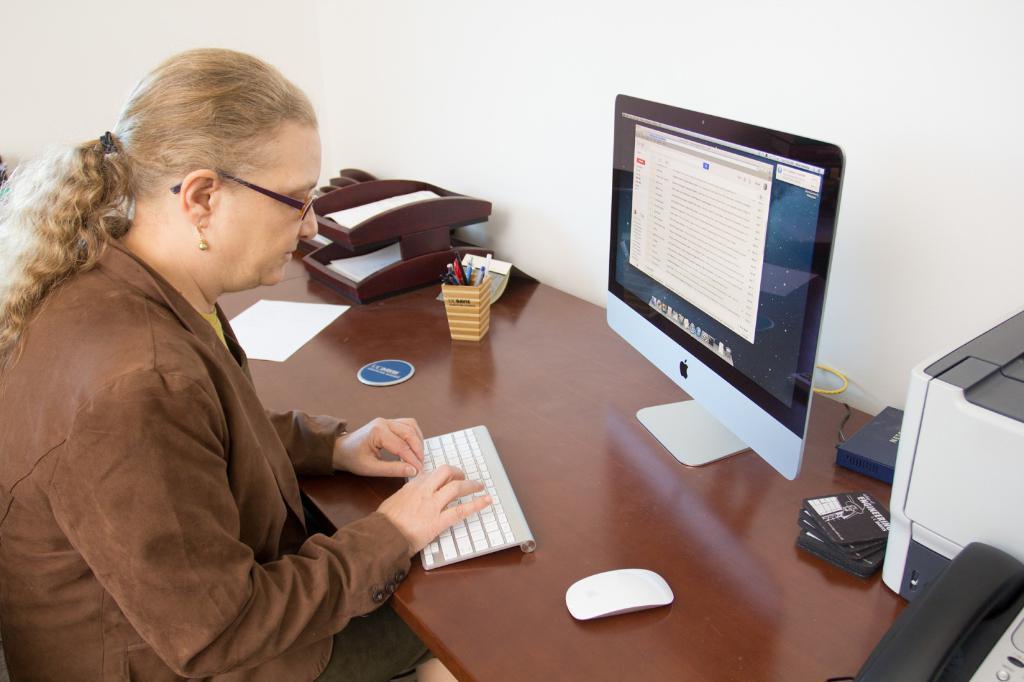Could you give a brief overview of what you see in this image? A woman who wore a brown jacket with grey hair have spectacles with the system which is on the table. And the table has some things like pen stand, paper, paper stand and also has a mouse and a telephone and printer machine on the table. 